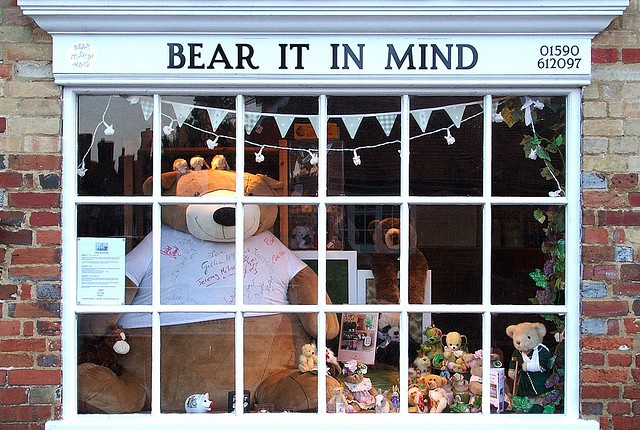Describe the objects in this image and their specific colors. I can see teddy bear in gray, maroon, darkgray, and brown tones, teddy bear in gray, black, darkgray, and teal tones, teddy bear in gray, black, maroon, tan, and brown tones, teddy bear in gray, lightgray, brown, lightpink, and darkgray tones, and teddy bear in gray, black, and darkgray tones in this image. 